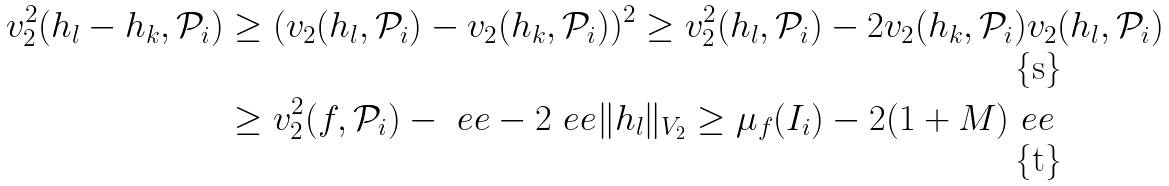Convert formula to latex. <formula><loc_0><loc_0><loc_500><loc_500>v _ { 2 } ^ { 2 } ( h _ { l } - h _ { k } , \mathcal { P } _ { i } ) & \geq ( v _ { 2 } ( h _ { l } , \mathcal { P } _ { i } ) - v _ { 2 } ( h _ { k } , \mathcal { P } _ { i } ) ) ^ { 2 } \geq v _ { 2 } ^ { 2 } ( h _ { l } , \mathcal { P } _ { i } ) - 2 v _ { 2 } ( h _ { k } , \mathcal { P } _ { i } ) v _ { 2 } ( h _ { l } , \mathcal { P } _ { i } ) \\ & \geq v _ { 2 } ^ { 2 } ( f , \mathcal { P } _ { i } ) - \ e e - 2 \ e e \| h _ { l } \| _ { V _ { 2 } } \geq \mu _ { f } ( I _ { i } ) - 2 ( 1 + M ) \ e e</formula> 